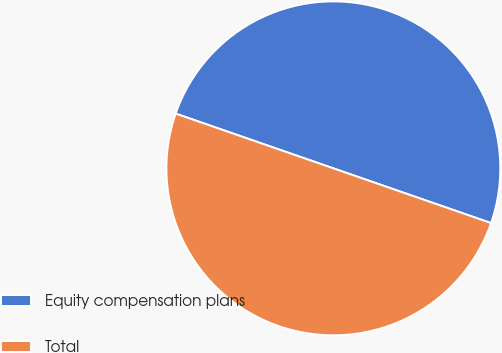Convert chart to OTSL. <chart><loc_0><loc_0><loc_500><loc_500><pie_chart><fcel>Equity compensation plans<fcel>Total<nl><fcel>50.0%<fcel>50.0%<nl></chart> 